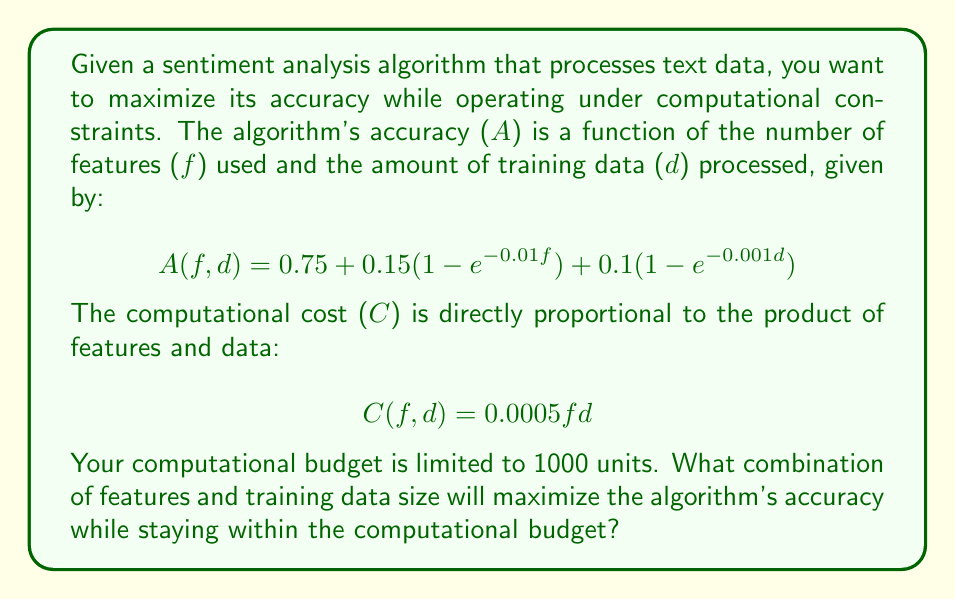What is the answer to this math problem? To solve this problem, we need to maximize $A(f,d)$ subject to the constraint $C(f,d) \leq 1000$. This is a constrained optimization problem that can be solved using the method of Lagrange multipliers.

1. First, let's form the Lagrangian function:
   $$L(f,d,\lambda) = A(f,d) - \lambda(C(f,d) - 1000)$$

2. We then take partial derivatives and set them to zero:
   $$\frac{\partial L}{\partial f} = 0.15 \cdot 0.01e^{-0.01f} - \lambda \cdot 0.0005d = 0$$
   $$\frac{\partial L}{\partial d} = 0.1 \cdot 0.001e^{-0.001d} - \lambda \cdot 0.0005f = 0$$
   $$\frac{\partial L}{\partial \lambda} = 1000 - 0.0005fd = 0$$

3. From the first two equations:
   $$0.15 \cdot 0.01e^{-0.01f} = \lambda \cdot 0.0005d$$
   $$0.1 \cdot 0.001e^{-0.001d} = \lambda \cdot 0.0005f$$

4. Dividing these equations:
   $$\frac{0.15 \cdot 0.01e^{-0.01f}}{0.1 \cdot 0.001e^{-0.001d}} = \frac{d}{f}$$
   $$15e^{-0.01f} = e^{-0.001d}$$
   $$\ln(15) - 0.01f = -0.001d$$
   $$d = 1000(\ln(15) - 0.01f)$$

5. Substituting this into the constraint equation:
   $$1000 = 0.0005f \cdot 1000(\ln(15) - 0.01f)$$
   $$2 = f(\ln(15) - 0.01f)$$

6. This equation can be solved numerically, yielding $f \approx 141.42$.

7. Substituting back:
   $$d = 1000(\ln(15) - 0.01 \cdot 141.42) \approx 1414.21$$

8. We can verify that this satisfies the constraint:
   $$C(141.42, 1414.21) = 0.0005 \cdot 141.42 \cdot 1414.21 \approx 1000$$

9. The maximum accuracy is therefore:
   $$A(141.42, 1414.21) = 0.75 + 0.15(1 - e^{-0.01 \cdot 141.42}) + 0.1(1 - e^{-0.001 \cdot 1414.21}) \approx 0.9761$$
Answer: The optimal solution is to use approximately 141 features and 1414 training data points, resulting in a maximum accuracy of about 0.9761 or 97.61%. 